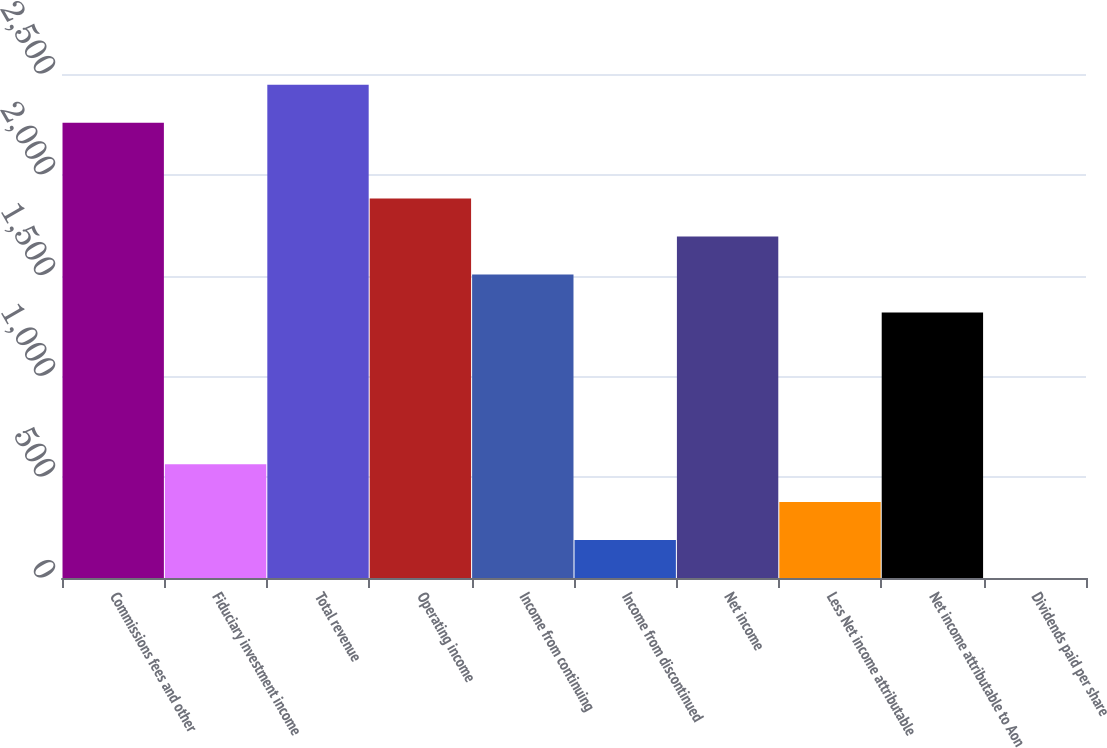Convert chart to OTSL. <chart><loc_0><loc_0><loc_500><loc_500><bar_chart><fcel>Commissions fees and other<fcel>Fiduciary investment income<fcel>Total revenue<fcel>Operating income<fcel>Income from continuing<fcel>Income from discontinued<fcel>Net income<fcel>Less Net income attributable<fcel>Net income attributable to Aon<fcel>Dividends paid per share<nl><fcel>2258.34<fcel>564.7<fcel>2446.53<fcel>1881.98<fcel>1505.62<fcel>188.34<fcel>1693.8<fcel>376.52<fcel>1317.44<fcel>0.15<nl></chart> 